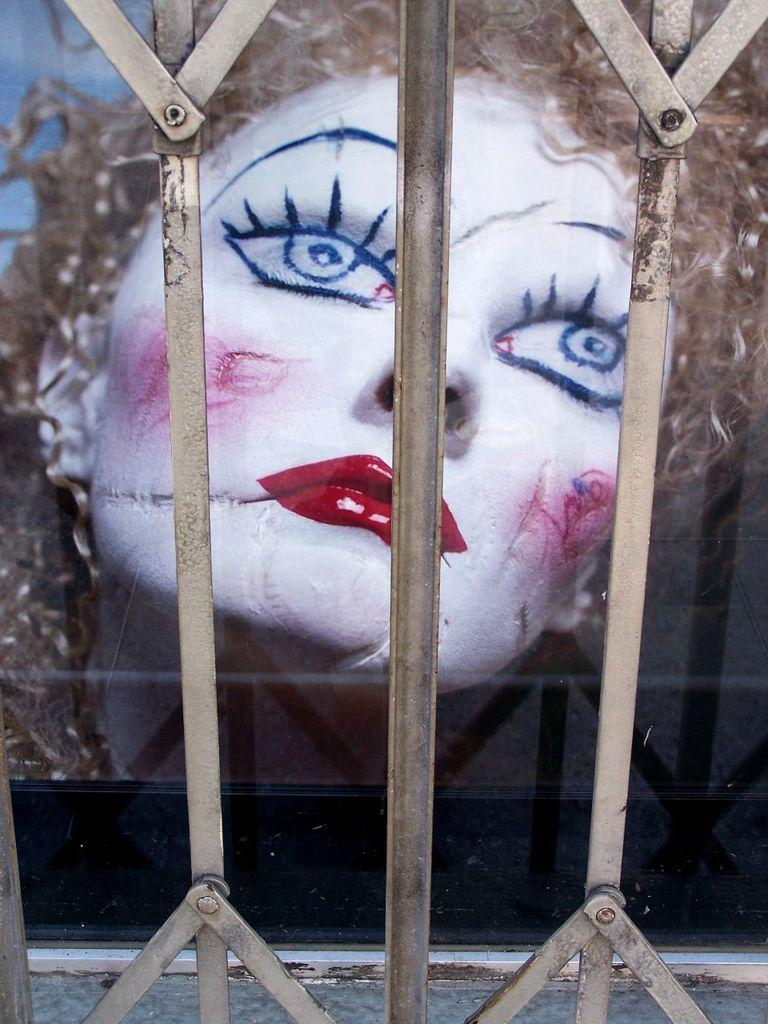What is depicted on the screen in the image? There is a painting of a person on the screen. What can be seen in the foreground of the image? There is a railing in the foreground of the image. What time is displayed on the hour in the image? There is no hour or clock present in the image, so it is not possible to determine the time. Can you see a loaf of bread in the image? There is no loaf of bread present in the image. 